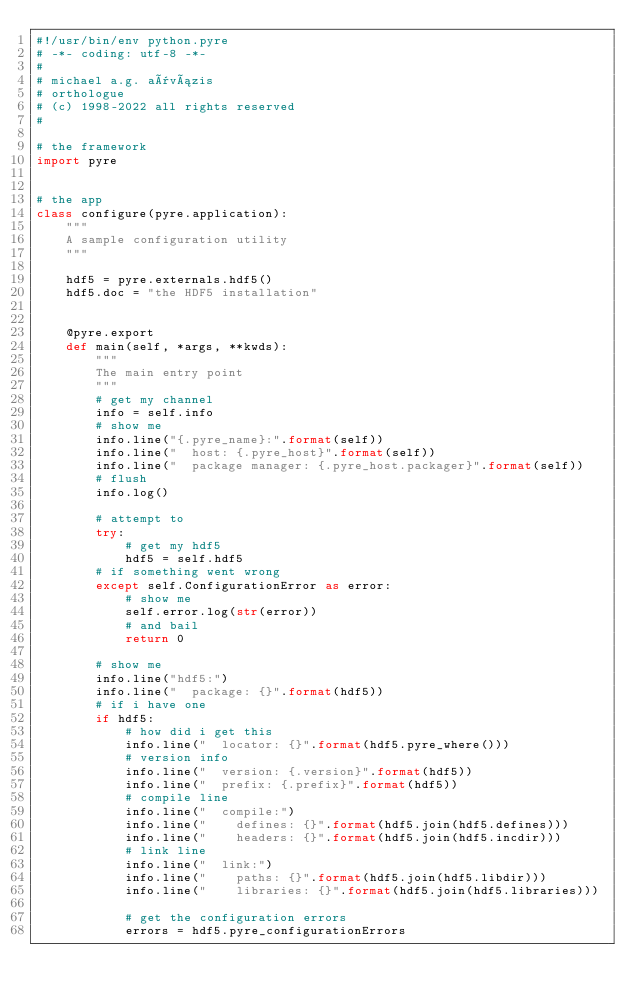Convert code to text. <code><loc_0><loc_0><loc_500><loc_500><_Python_>#!/usr/bin/env python.pyre
# -*- coding: utf-8 -*-
#
# michael a.g. aïvázis
# orthologue
# (c) 1998-2022 all rights reserved
#

# the framework
import pyre


# the app
class configure(pyre.application):
    """
    A sample configuration utility
    """

    hdf5 = pyre.externals.hdf5()
    hdf5.doc = "the HDF5 installation"


    @pyre.export
    def main(self, *args, **kwds):
        """
        The main entry point
        """
        # get my channel
        info = self.info
        # show me
        info.line("{.pyre_name}:".format(self))
        info.line("  host: {.pyre_host}".format(self))
        info.line("  package manager: {.pyre_host.packager}".format(self))
        # flush
        info.log()

        # attempt to
        try:
            # get my hdf5
            hdf5 = self.hdf5
        # if something went wrong
        except self.ConfigurationError as error:
            # show me
            self.error.log(str(error))
            # and bail
            return 0

        # show me
        info.line("hdf5:")
        info.line("  package: {}".format(hdf5))
        # if i have one
        if hdf5:
            # how did i get this
            info.line("  locator: {}".format(hdf5.pyre_where()))
            # version info
            info.line("  version: {.version}".format(hdf5))
            info.line("  prefix: {.prefix}".format(hdf5))
            # compile line
            info.line("  compile:")
            info.line("    defines: {}".format(hdf5.join(hdf5.defines)))
            info.line("    headers: {}".format(hdf5.join(hdf5.incdir)))
            # link line
            info.line("  link:")
            info.line("    paths: {}".format(hdf5.join(hdf5.libdir)))
            info.line("    libraries: {}".format(hdf5.join(hdf5.libraries)))

            # get the configuration errors
            errors = hdf5.pyre_configurationErrors</code> 